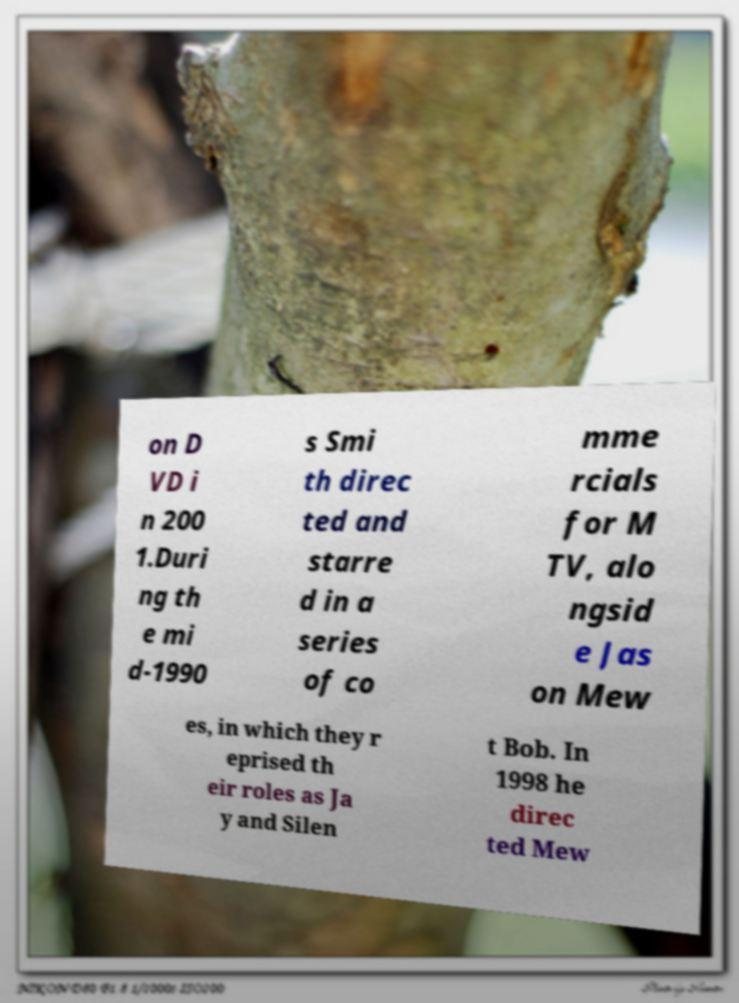What messages or text are displayed in this image? I need them in a readable, typed format. on D VD i n 200 1.Duri ng th e mi d-1990 s Smi th direc ted and starre d in a series of co mme rcials for M TV, alo ngsid e Jas on Mew es, in which they r eprised th eir roles as Ja y and Silen t Bob. In 1998 he direc ted Mew 